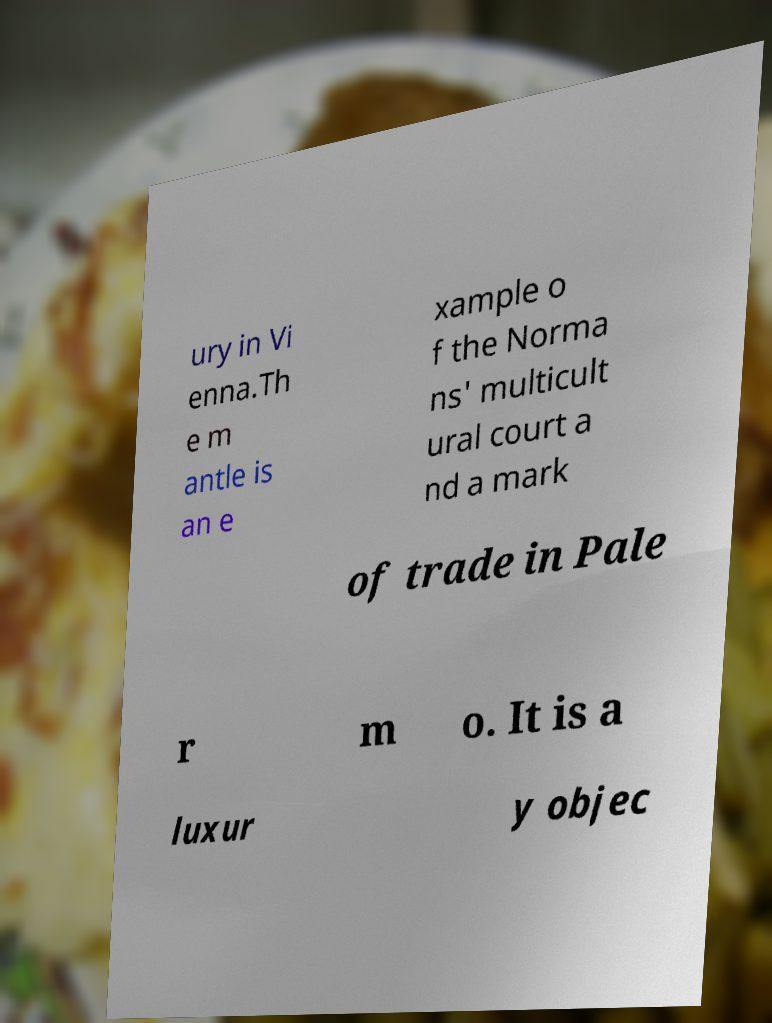There's text embedded in this image that I need extracted. Can you transcribe it verbatim? ury in Vi enna.Th e m antle is an e xample o f the Norma ns' multicult ural court a nd a mark of trade in Pale r m o. It is a luxur y objec 